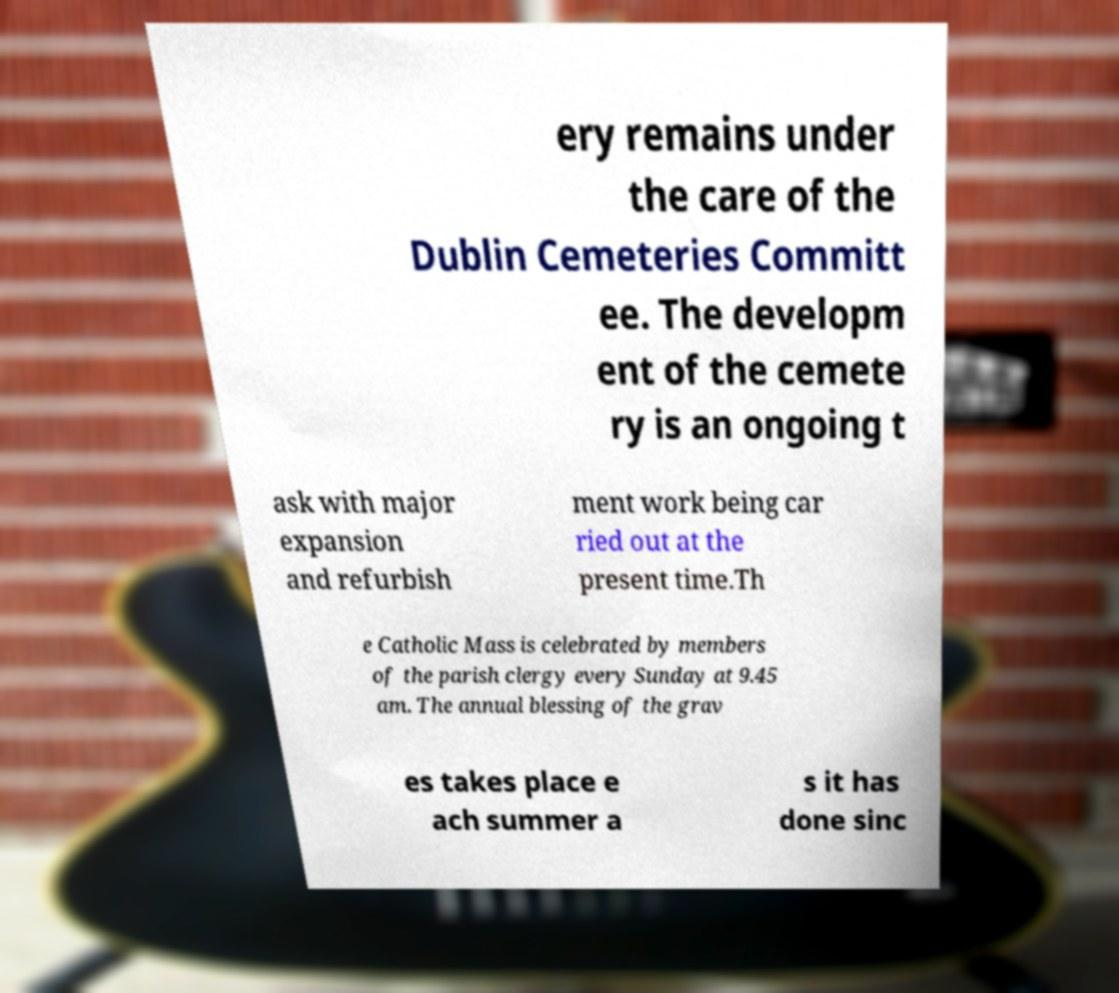Please read and relay the text visible in this image. What does it say? ery remains under the care of the Dublin Cemeteries Committ ee. The developm ent of the cemete ry is an ongoing t ask with major expansion and refurbish ment work being car ried out at the present time.Th e Catholic Mass is celebrated by members of the parish clergy every Sunday at 9.45 am. The annual blessing of the grav es takes place e ach summer a s it has done sinc 